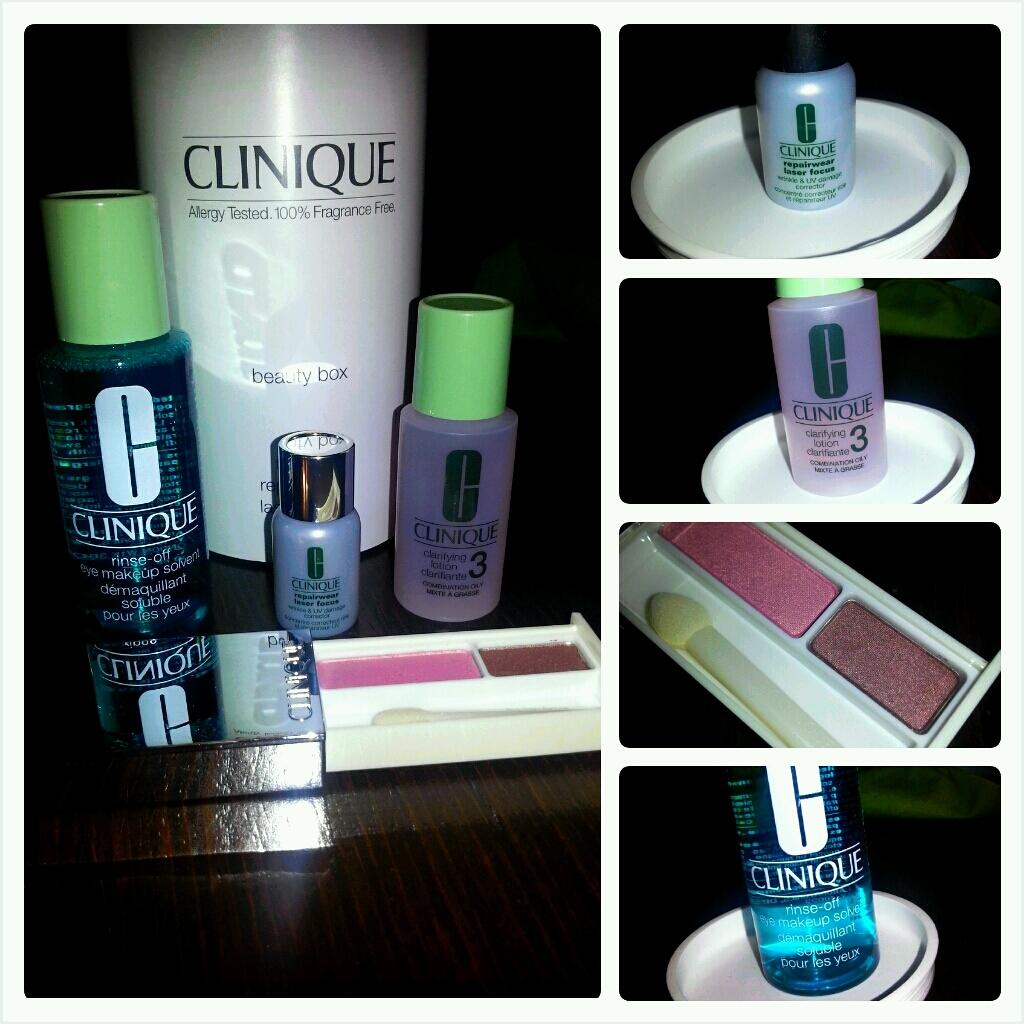<image>
Render a clear and concise summary of the photo. different bottles of clinique face products and makeup 